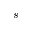<formula> <loc_0><loc_0><loc_500><loc_500>s</formula> 